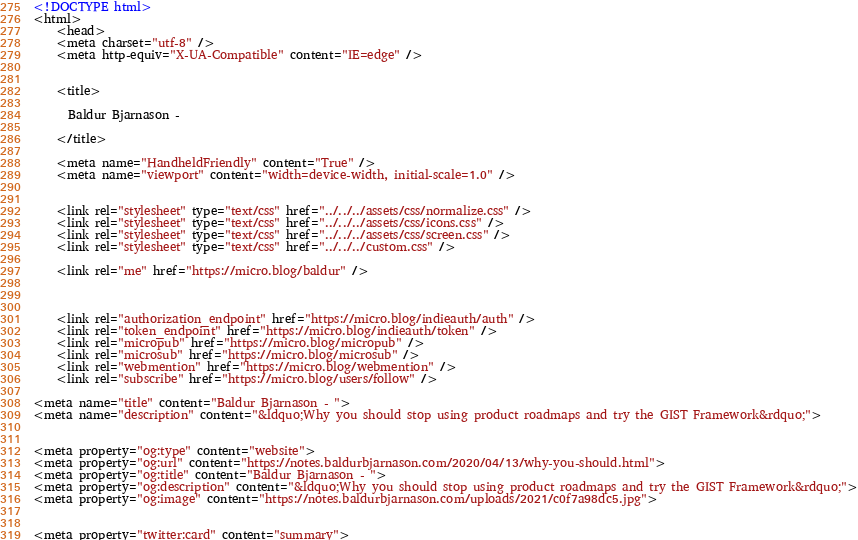<code> <loc_0><loc_0><loc_500><loc_500><_HTML_><!DOCTYPE html>
<html>
    <head>
    <meta charset="utf-8" />
    <meta http-equiv="X-UA-Compatible" content="IE=edge" />

    
    <title>
      
      Baldur Bjarnason - 
      
	</title>

    <meta name="HandheldFriendly" content="True" />
    <meta name="viewport" content="width=device-width, initial-scale=1.0" />

    
    <link rel="stylesheet" type="text/css" href="../../../assets/css/normalize.css" />
    <link rel="stylesheet" type="text/css" href="../../../assets/css/icons.css" />
    <link rel="stylesheet" type="text/css" href="../../../assets/css/screen.css" />
    <link rel="stylesheet" type="text/css" href="../../../custom.css" />

	<link rel="me" href="https://micro.blog/baldur" />
	
	
	
	<link rel="authorization_endpoint" href="https://micro.blog/indieauth/auth" />
	<link rel="token_endpoint" href="https://micro.blog/indieauth/token" />
	<link rel="micropub" href="https://micro.blog/micropub" />
	<link rel="microsub" href="https://micro.blog/microsub" />
	<link rel="webmention" href="https://micro.blog/webmention" />
	<link rel="subscribe" href="https://micro.blog/users/follow" />

<meta name="title" content="Baldur Bjarnason - ">
<meta name="description" content="&ldquo;Why you should stop using product roadmaps and try the GIST Framework&rdquo;">


<meta property="og:type" content="website">
<meta property="og:url" content="https://notes.baldurbjarnason.com/2020/04/13/why-you-should.html">
<meta property="og:title" content="Baldur Bjarnason - ">
<meta property="og:description" content="&ldquo;Why you should stop using product roadmaps and try the GIST Framework&rdquo;">
<meta property="og:image" content="https://notes.baldurbjarnason.com/uploads/2021/c0f7a98dc5.jpg">


<meta property="twitter:card" content="summary"></code> 